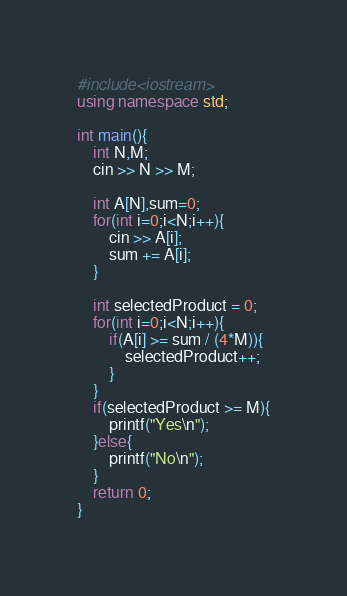Convert code to text. <code><loc_0><loc_0><loc_500><loc_500><_C++_>#include<iostream>
using namespace std;

int main(){
    int N,M;
    cin >> N >> M;
    
    int A[N],sum=0;
    for(int i=0;i<N;i++){
        cin >> A[i];
        sum += A[i];
    }

    int selectedProduct = 0;
    for(int i=0;i<N;i++){
        if(A[i] >= sum / (4*M)){
            selectedProduct++;
        }
    }
    if(selectedProduct >= M){
        printf("Yes\n");
    }else{
        printf("No\n");
    }
    return 0;
}</code> 